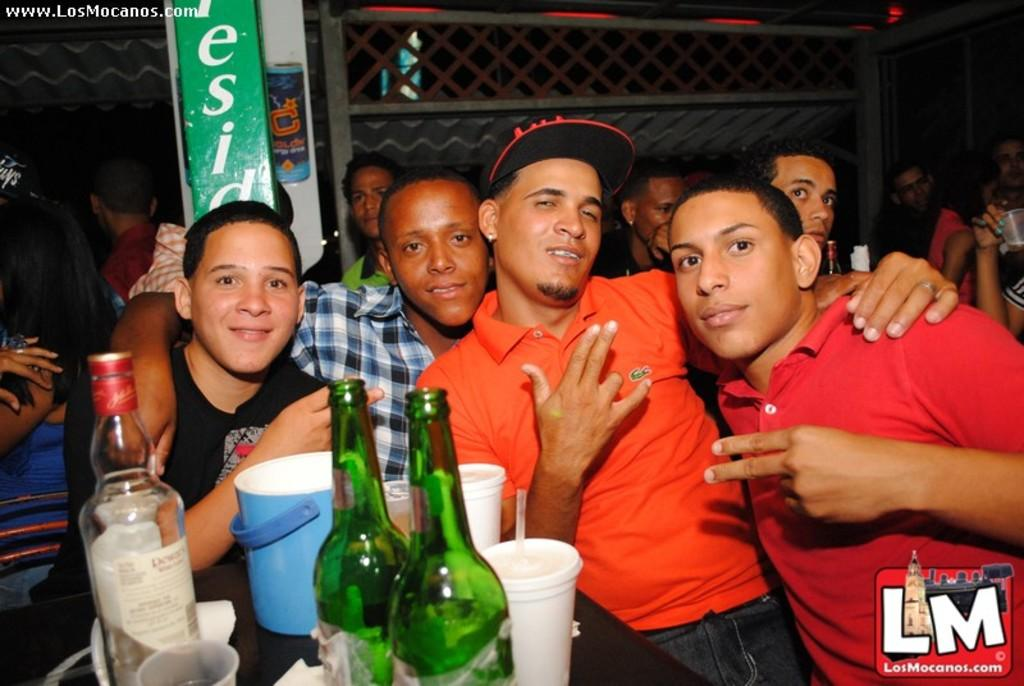What are the people in the image doing? The people in the image are sitting. What can be seen on the table in the image? There is a wine glass, a wine bottle, and a bucket of ice cubes on the table. What type of gate is visible in the image? There is no gate present in the image. How many plates are on the table in the image? There is no plate visible in the image. 